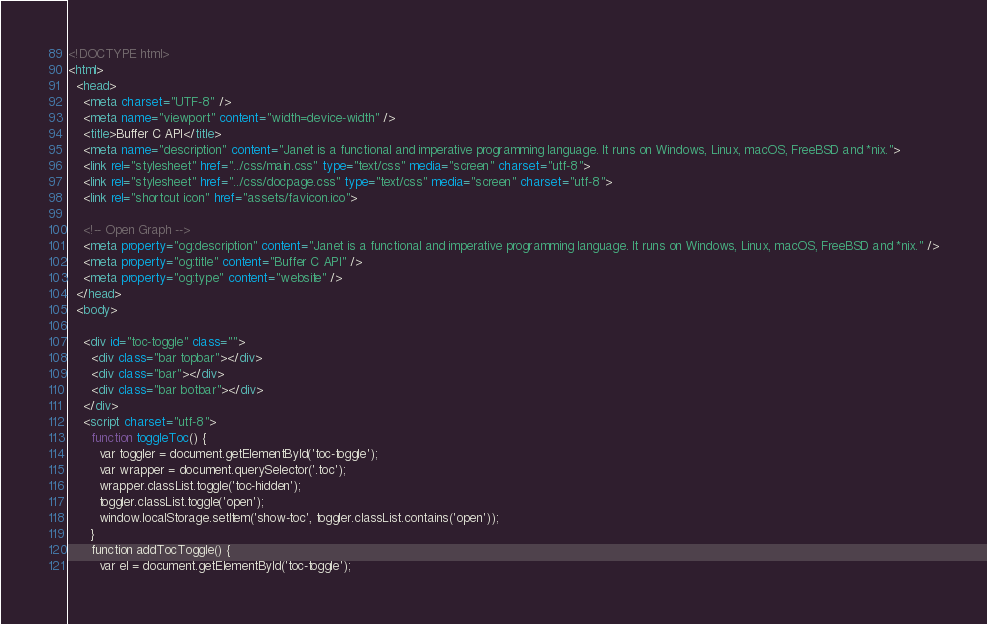Convert code to text. <code><loc_0><loc_0><loc_500><loc_500><_HTML_>
<!DOCTYPE html>
<html>
  <head>
    <meta charset="UTF-8" />
    <meta name="viewport" content="width=device-width" />
    <title>Buffer C API</title>
    <meta name="description" content="Janet is a functional and imperative programming language. It runs on Windows, Linux, macOS, FreeBSD and *nix.">
    <link rel="stylesheet" href="../css/main.css" type="text/css" media="screen" charset="utf-8">
    <link rel="stylesheet" href="../css/docpage.css" type="text/css" media="screen" charset="utf-8">
    <link rel="shortcut icon" href="assets/favicon.ico">

    <!-- Open Graph -->
    <meta property="og:description" content="Janet is a functional and imperative programming language. It runs on Windows, Linux, macOS, FreeBSD and *nix." />
    <meta property="og:title" content="Buffer C API" />
    <meta property="og:type" content="website" />
  </head>
  <body>

    <div id="toc-toggle" class="">
      <div class="bar topbar"></div>
      <div class="bar"></div>
      <div class="bar botbar"></div>
    </div>
    <script charset="utf-8">
      function toggleToc() {
        var toggler = document.getElementById('toc-toggle');
        var wrapper = document.querySelector('.toc');
        wrapper.classList.toggle('toc-hidden');
        toggler.classList.toggle('open');
        window.localStorage.setItem('show-toc', toggler.classList.contains('open'));
      }
      function addTocToggle() {
        var el = document.getElementById('toc-toggle');</code> 